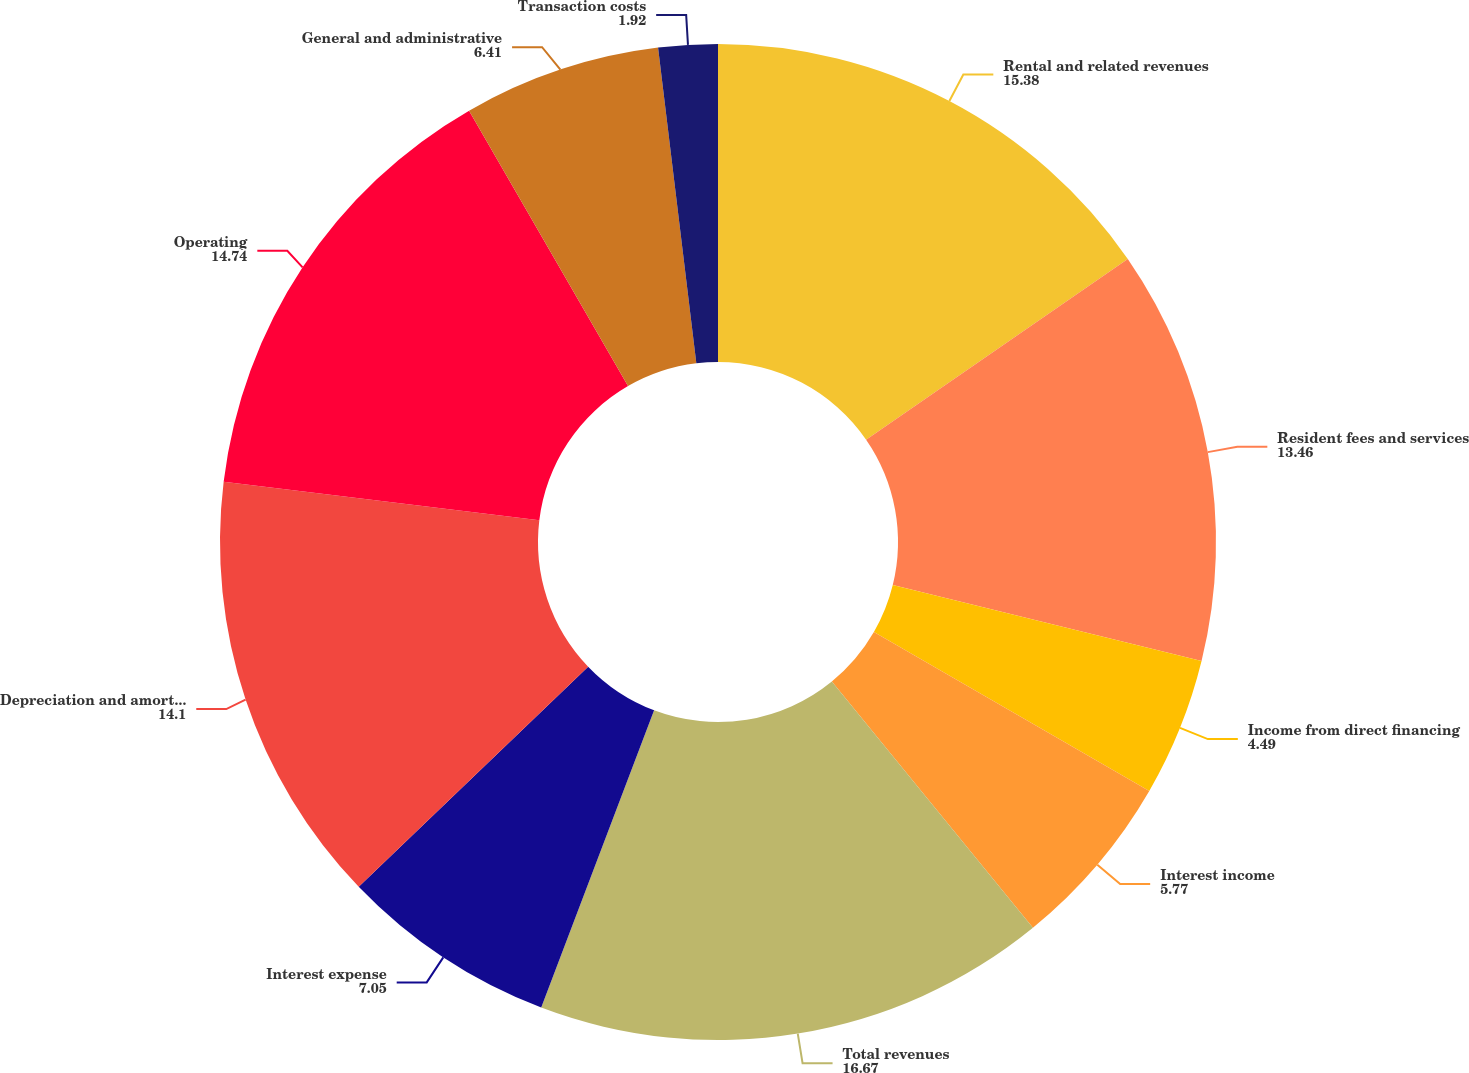<chart> <loc_0><loc_0><loc_500><loc_500><pie_chart><fcel>Rental and related revenues<fcel>Resident fees and services<fcel>Income from direct financing<fcel>Interest income<fcel>Total revenues<fcel>Interest expense<fcel>Depreciation and amortization<fcel>Operating<fcel>General and administrative<fcel>Transaction costs<nl><fcel>15.38%<fcel>13.46%<fcel>4.49%<fcel>5.77%<fcel>16.67%<fcel>7.05%<fcel>14.1%<fcel>14.74%<fcel>6.41%<fcel>1.92%<nl></chart> 